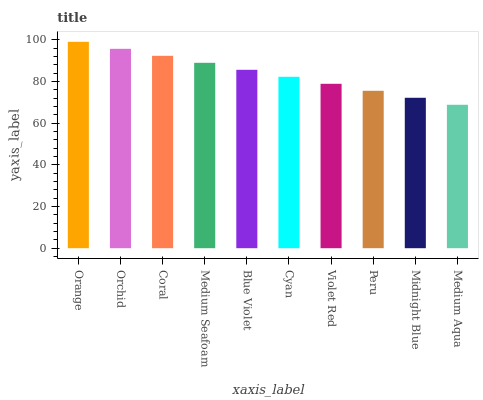Is Medium Aqua the minimum?
Answer yes or no. Yes. Is Orange the maximum?
Answer yes or no. Yes. Is Orchid the minimum?
Answer yes or no. No. Is Orchid the maximum?
Answer yes or no. No. Is Orange greater than Orchid?
Answer yes or no. Yes. Is Orchid less than Orange?
Answer yes or no. Yes. Is Orchid greater than Orange?
Answer yes or no. No. Is Orange less than Orchid?
Answer yes or no. No. Is Blue Violet the high median?
Answer yes or no. Yes. Is Cyan the low median?
Answer yes or no. Yes. Is Orange the high median?
Answer yes or no. No. Is Blue Violet the low median?
Answer yes or no. No. 